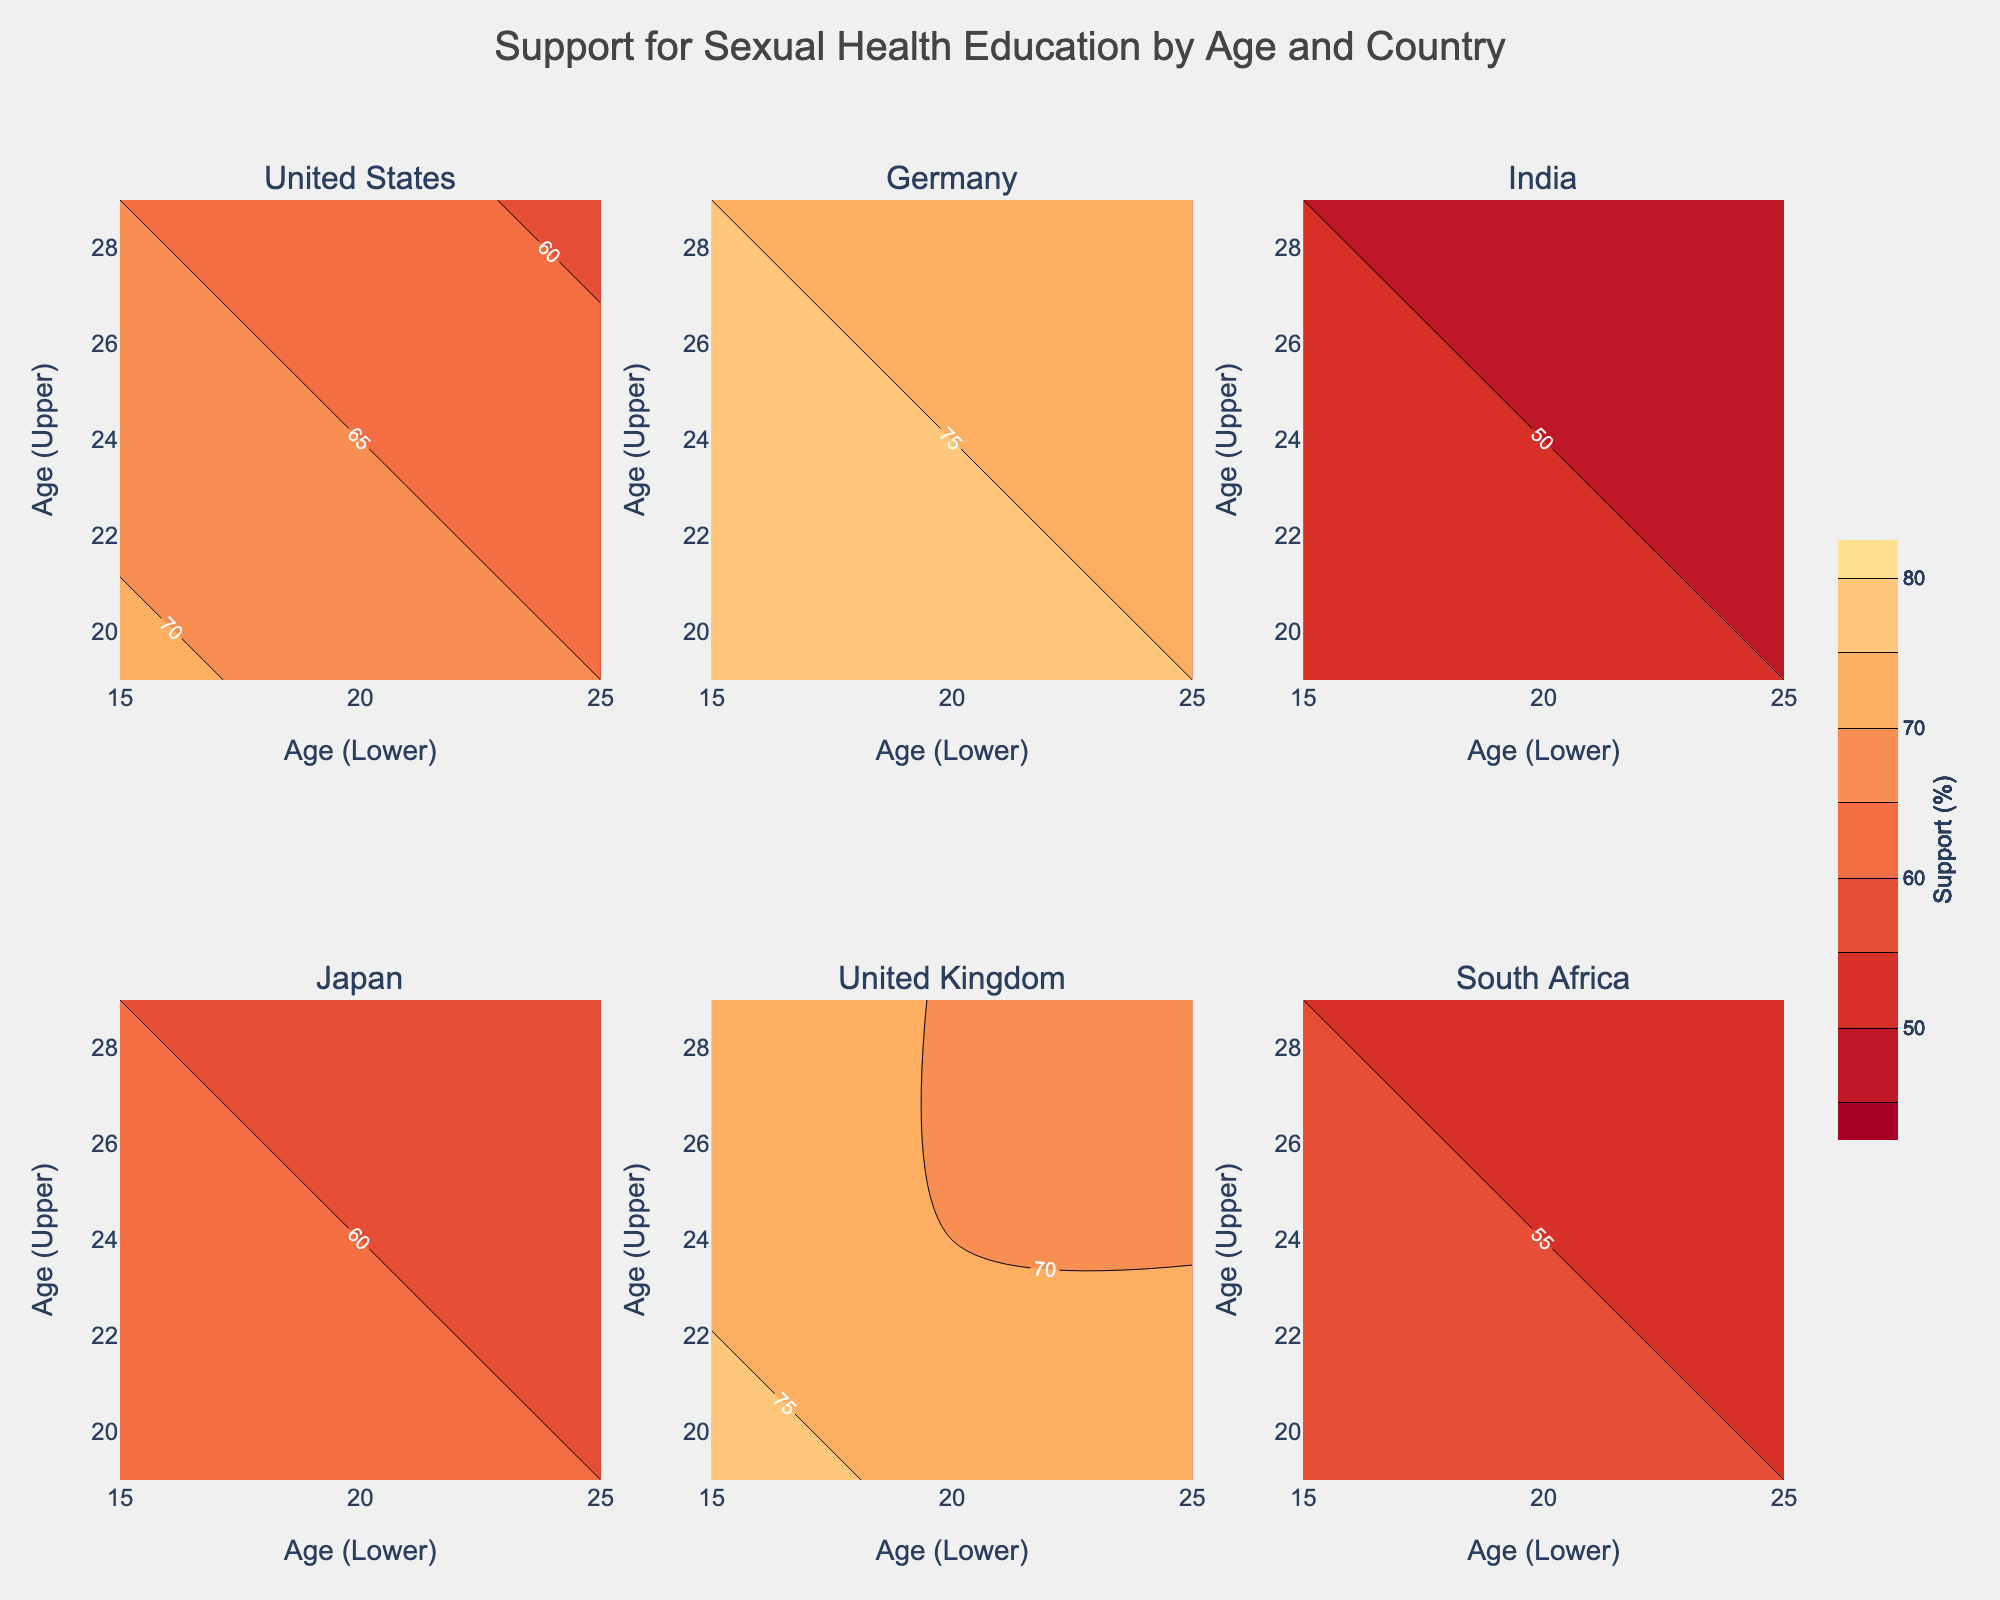What is the title of the figure? The title of the figure is displayed prominently at the top. It reads "Support for Sexual Health Education by Age and Country". This provides an overview of the figure's purpose.
Answer: Support for Sexual Health Education by Age and Country Which country has the highest support for sexual health education among the 15-19 age group? To identify the country with the highest support among the 15-19 age group, look at the contour level with the highest percentage value in the respective subplot. Germany has the highest support level of 80% for the 15-19 age group.
Answer: Germany What is the color representing the minimum support value in the plots? The minimum support value in the plots is 45%, and referring to the colorscale at the bottom of the plots, the corresponding color is a shade of dark red.
Answer: Dark red How does the support for sexual health education change with age in Japan? To understand the trend in Japan, examine the contour plots for each age group. For Japan, the support drops from 65% in the 15-19 age group to 60% in the 20-24 group and further down to 55% in the 25-29 group, indicating a consistent decline.
Answer: Declines Compare the support for sexual health education between Germany and South Africa for the 20-24 age group. To compare support levels, check the contour labels for the 20-24 age plot in the respective subplots. Germany shows a support level of 75%, whereas South Africa shows 55%. Hence, Germany has a significantly higher support level.
Answer: Germany has higher support (75% vs 55%) Which country's support shows the least change across different age groups? The change across age groups can be assessed by the difference between the highest and lowest support values. United Kingdom moves from 78% to 68%, which is a 10% change, one of the smallest range changes.
Answer: United Kingdom What age group has the highest overall support for sexual health education across all countries? Looking at the highest contour labels across all countries can identify the age group with the highest support. The 15-19 age group shows the highest support overall, with Germany reaching 80% and the United Kingdom at 78%.
Answer: 15-19 Between the United States and India, which country shows a steeper decline in support as age increases? A steeper decline can be determined by looking at the difference in support percentages from the youngest to the oldest age group. The United States shows a decline from 72% to 58% (14% drop), while India shows a decline from 55% to 45% (10% drop). The United States thus has a steeper decline.
Answer: United States Which country has the lowest support for sexual health education among the 25-29 age group? Check the contour plot for each country focusing on the 25-29 age group. India shows the lowest support at 45%.
Answer: India 